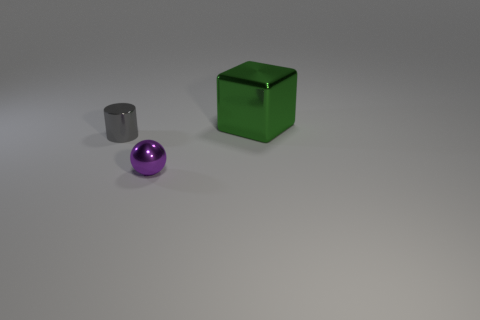Add 1 tiny purple objects. How many objects exist? 4 Subtract all cubes. How many objects are left? 2 Subtract 0 gray balls. How many objects are left? 3 Subtract all purple objects. Subtract all small cylinders. How many objects are left? 1 Add 1 small purple metal spheres. How many small purple metal spheres are left? 2 Add 1 large red matte spheres. How many large red matte spheres exist? 1 